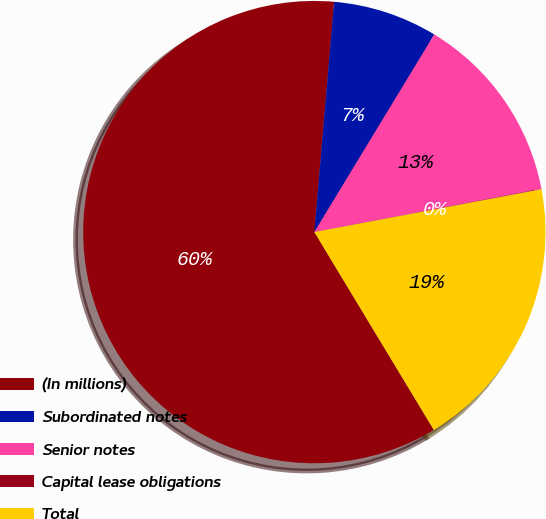Convert chart. <chart><loc_0><loc_0><loc_500><loc_500><pie_chart><fcel>(In millions)<fcel>Subordinated notes<fcel>Senior notes<fcel>Capital lease obligations<fcel>Total<nl><fcel>60.01%<fcel>7.32%<fcel>13.32%<fcel>0.03%<fcel>19.32%<nl></chart> 